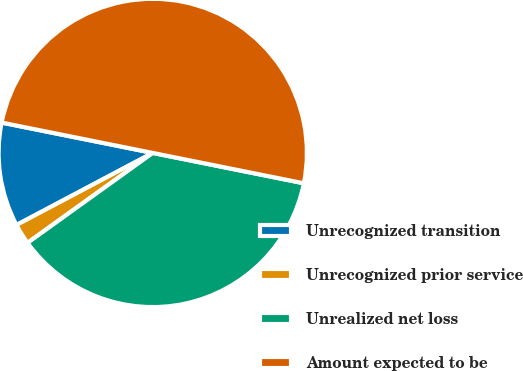<chart> <loc_0><loc_0><loc_500><loc_500><pie_chart><fcel>Unrecognized transition<fcel>Unrecognized prior service<fcel>Unrealized net loss<fcel>Amount expected to be<nl><fcel>10.9%<fcel>2.17%<fcel>36.93%<fcel>50.0%<nl></chart> 